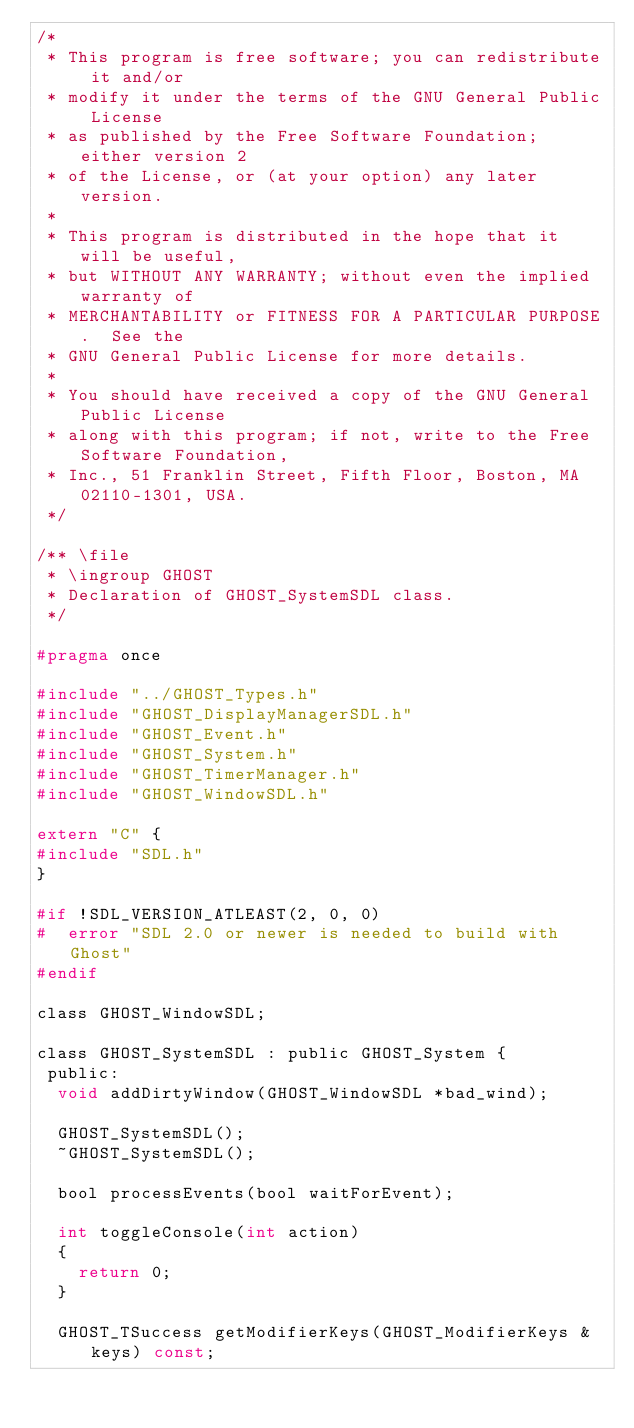Convert code to text. <code><loc_0><loc_0><loc_500><loc_500><_C_>/*
 * This program is free software; you can redistribute it and/or
 * modify it under the terms of the GNU General Public License
 * as published by the Free Software Foundation; either version 2
 * of the License, or (at your option) any later version.
 *
 * This program is distributed in the hope that it will be useful,
 * but WITHOUT ANY WARRANTY; without even the implied warranty of
 * MERCHANTABILITY or FITNESS FOR A PARTICULAR PURPOSE.  See the
 * GNU General Public License for more details.
 *
 * You should have received a copy of the GNU General Public License
 * along with this program; if not, write to the Free Software Foundation,
 * Inc., 51 Franklin Street, Fifth Floor, Boston, MA 02110-1301, USA.
 */

/** \file
 * \ingroup GHOST
 * Declaration of GHOST_SystemSDL class.
 */

#pragma once

#include "../GHOST_Types.h"
#include "GHOST_DisplayManagerSDL.h"
#include "GHOST_Event.h"
#include "GHOST_System.h"
#include "GHOST_TimerManager.h"
#include "GHOST_WindowSDL.h"

extern "C" {
#include "SDL.h"
}

#if !SDL_VERSION_ATLEAST(2, 0, 0)
#  error "SDL 2.0 or newer is needed to build with Ghost"
#endif

class GHOST_WindowSDL;

class GHOST_SystemSDL : public GHOST_System {
 public:
  void addDirtyWindow(GHOST_WindowSDL *bad_wind);

  GHOST_SystemSDL();
  ~GHOST_SystemSDL();

  bool processEvents(bool waitForEvent);

  int toggleConsole(int action)
  {
    return 0;
  }

  GHOST_TSuccess getModifierKeys(GHOST_ModifierKeys &keys) const;
</code> 